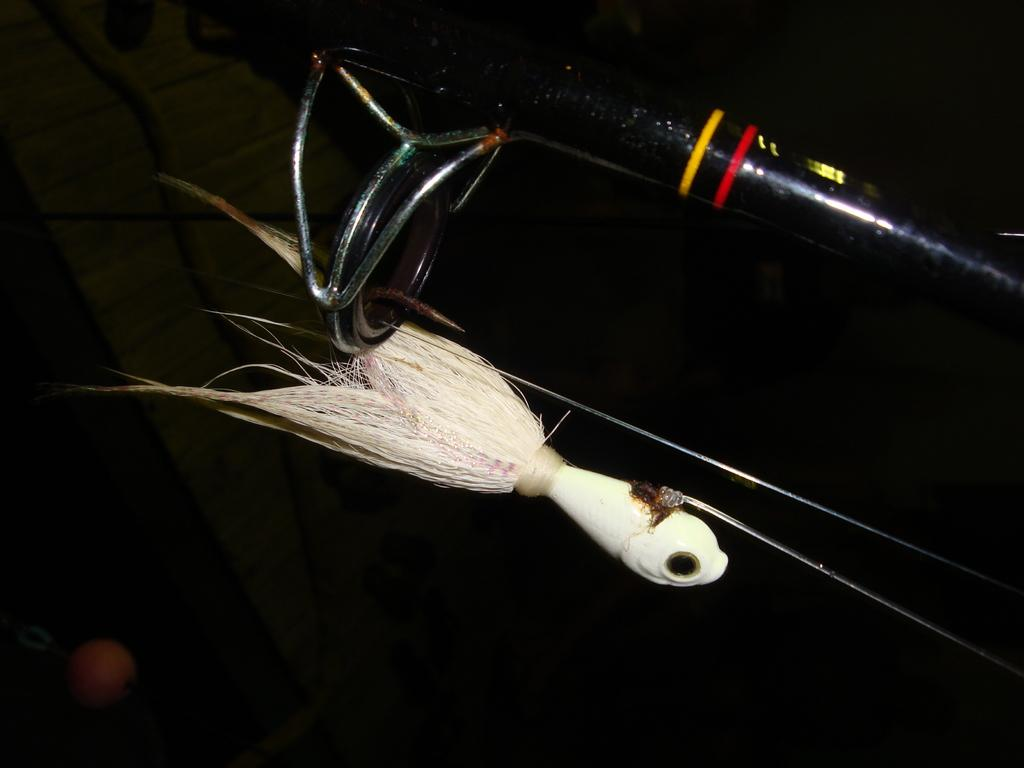What is the main object in the image? There is a bird toy in the image. How is the bird toy positioned in the image? The bird toy is on a stand. What can be observed about the background of the image? The background of the image is dark. What type of fog can be seen surrounding the bird toy in the image? There is no fog present in the image; the background is simply dark. 